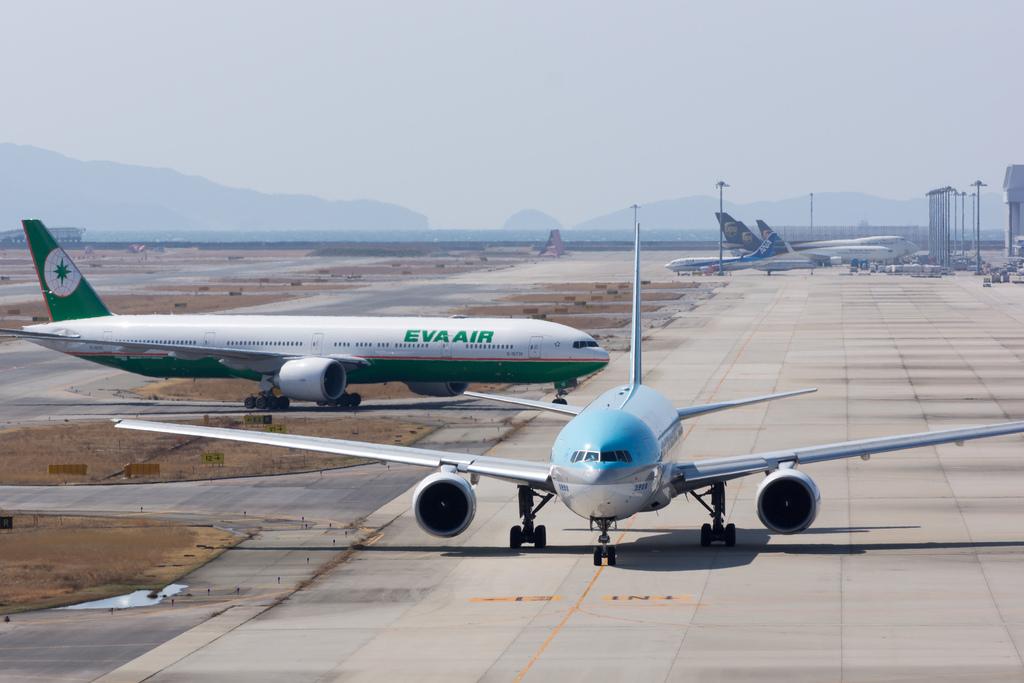Which airline company operates the green aeroplane?
Ensure brevity in your answer.  Eva air. 